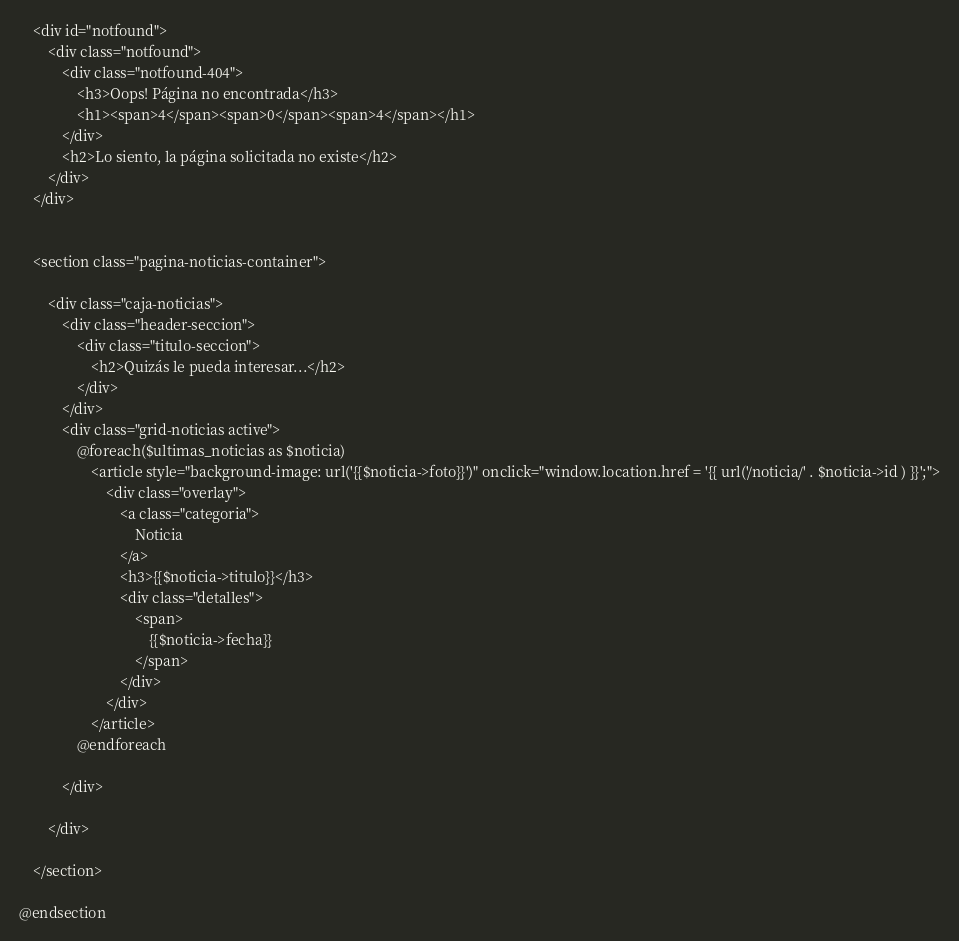Convert code to text. <code><loc_0><loc_0><loc_500><loc_500><_PHP_>


    <div id="notfound">
        <div class="notfound">
            <div class="notfound-404">
                <h3>Oops! Página no encontrada</h3>
                <h1><span>4</span><span>0</span><span>4</span></h1>
            </div>
            <h2>Lo siento, la página solicitada no existe</h2>
        </div>
    </div>


    <section class="pagina-noticias-container">

        <div class="caja-noticias">
            <div class="header-seccion">
                <div class="titulo-seccion">
                    <h2>Quizás le pueda interesar...</h2>
                </div>
            </div>
            <div class="grid-noticias active">
                @foreach($ultimas_noticias as $noticia)
                    <article style="background-image: url('{{$noticia->foto}}')" onclick="window.location.href = '{{ url('/noticia/' . $noticia->id ) }}';">
                        <div class="overlay">
                            <a class="categoria">
                                Noticia
                            </a>
                            <h3>{{$noticia->titulo}}</h3>
                            <div class="detalles">
                                <span>
                                    {{$noticia->fecha}}
                                </span>
                            </div>
                        </div>
                    </article>
                @endforeach

            </div>

        </div>

    </section>

@endsection
</code> 